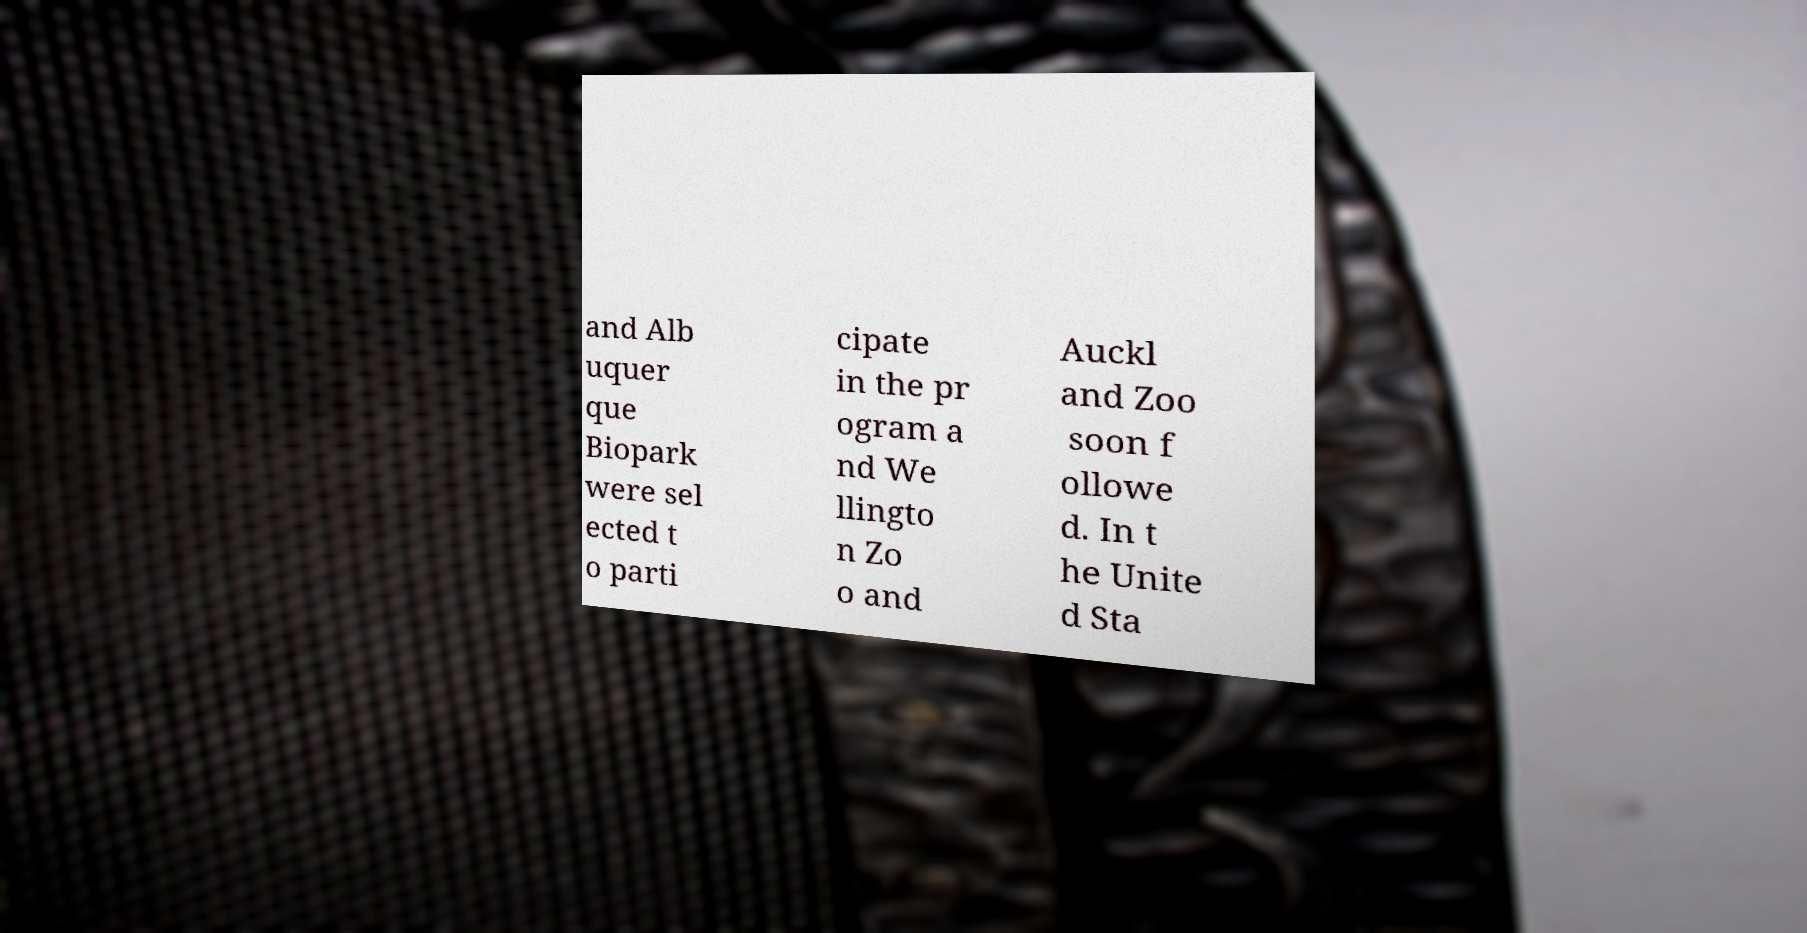Can you read and provide the text displayed in the image?This photo seems to have some interesting text. Can you extract and type it out for me? and Alb uquer que Biopark were sel ected t o parti cipate in the pr ogram a nd We llingto n Zo o and Auckl and Zoo soon f ollowe d. In t he Unite d Sta 